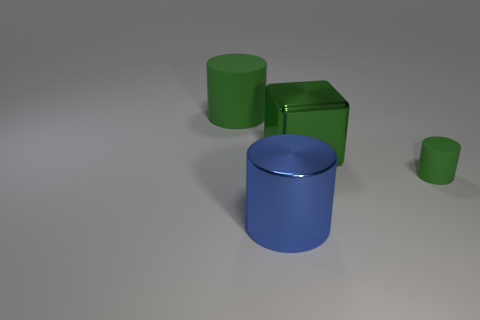The thing that is both to the right of the blue metal thing and behind the tiny matte thing is made of what material?
Your answer should be very brief. Metal. Is there a small cyan matte ball?
Ensure brevity in your answer.  No. Is the color of the small matte cylinder the same as the rubber cylinder that is to the left of the tiny thing?
Make the answer very short. Yes. What material is the cube that is the same color as the tiny cylinder?
Keep it short and to the point. Metal. Are there any other things that have the same shape as the green shiny thing?
Make the answer very short. No. The rubber thing that is behind the rubber object that is in front of the cylinder that is behind the metal cube is what shape?
Offer a terse response. Cylinder. The large green metallic object is what shape?
Provide a short and direct response. Cube. What is the color of the large cylinder that is behind the large block?
Provide a short and direct response. Green. There is a metallic thing behind the blue object; does it have the same size as the tiny green object?
Offer a terse response. No. What size is the blue object that is the same shape as the big green matte thing?
Your answer should be compact. Large. 